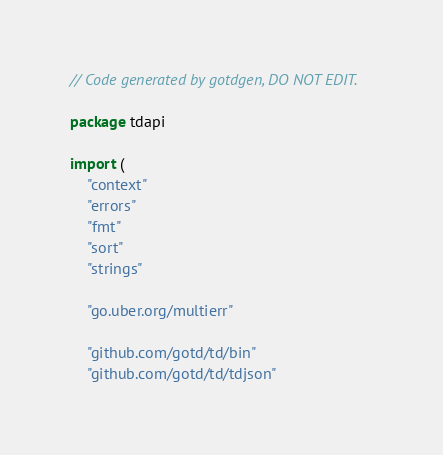Convert code to text. <code><loc_0><loc_0><loc_500><loc_500><_Go_>// Code generated by gotdgen, DO NOT EDIT.

package tdapi

import (
	"context"
	"errors"
	"fmt"
	"sort"
	"strings"

	"go.uber.org/multierr"

	"github.com/gotd/td/bin"
	"github.com/gotd/td/tdjson"</code> 